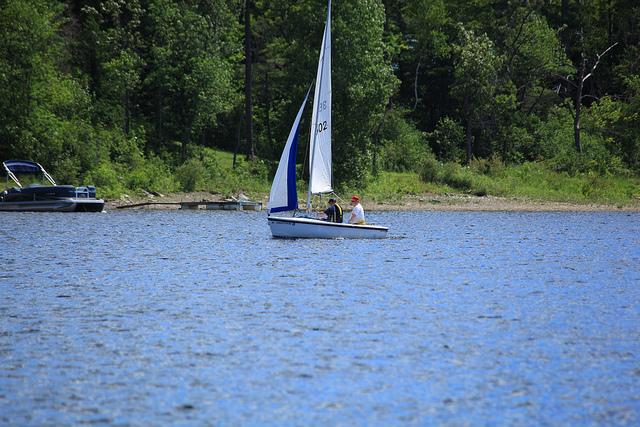Is it a sunny day?
Keep it brief. Yes. Is there more than one boat in the picture?
Be succinct. Yes. What color is the boat?
Concise answer only. White. Is the sail unfurled?
Concise answer only. Yes. Is the sail up or down?
Short answer required. Up. Who is wearing a Red Hat?
Be succinct. Man in white shirt. What is written on the sail behind the boat?
Write a very short answer. 02. Does the sailboat have a sail?
Quick response, please. Yes. 